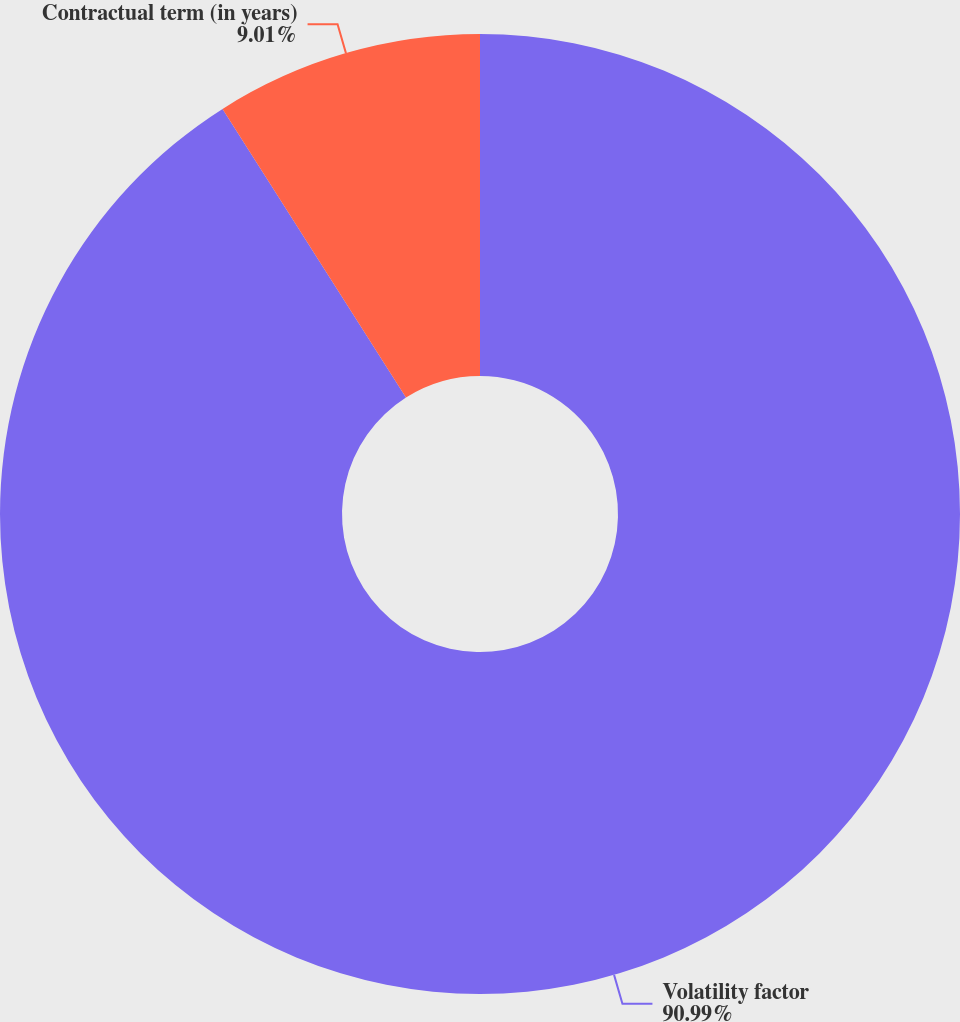Convert chart to OTSL. <chart><loc_0><loc_0><loc_500><loc_500><pie_chart><fcel>Volatility factor<fcel>Contractual term (in years)<nl><fcel>90.99%<fcel>9.01%<nl></chart> 